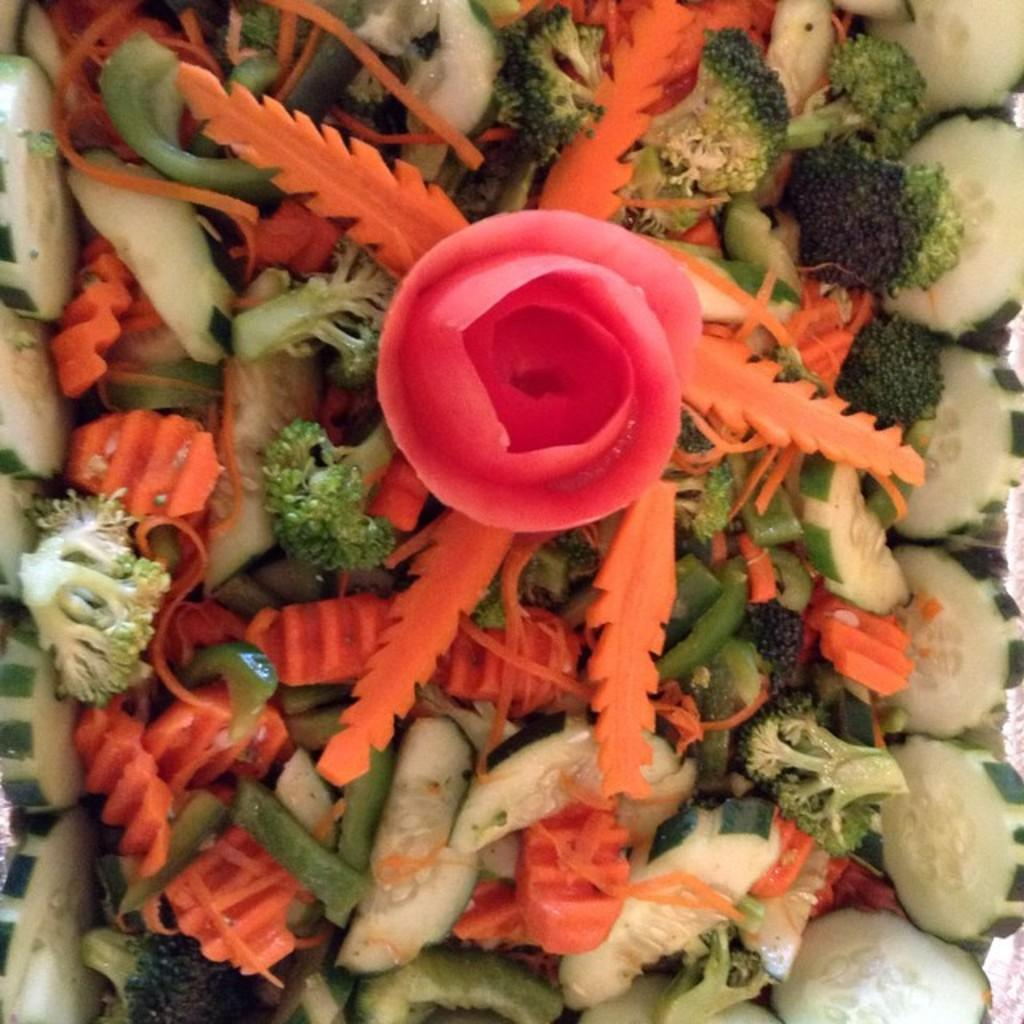What type of food can be seen in the image? There are colorful chopped vegetables in the image. Can you describe the appearance of the pink-colored object? There is a pink-colored object on top of the vegetables. What type of mailbox can be seen in the image? There is no mailbox present in the image. What is the weight of the land in the image? There is no land present in the image, so it is not possible to determine its weight. 